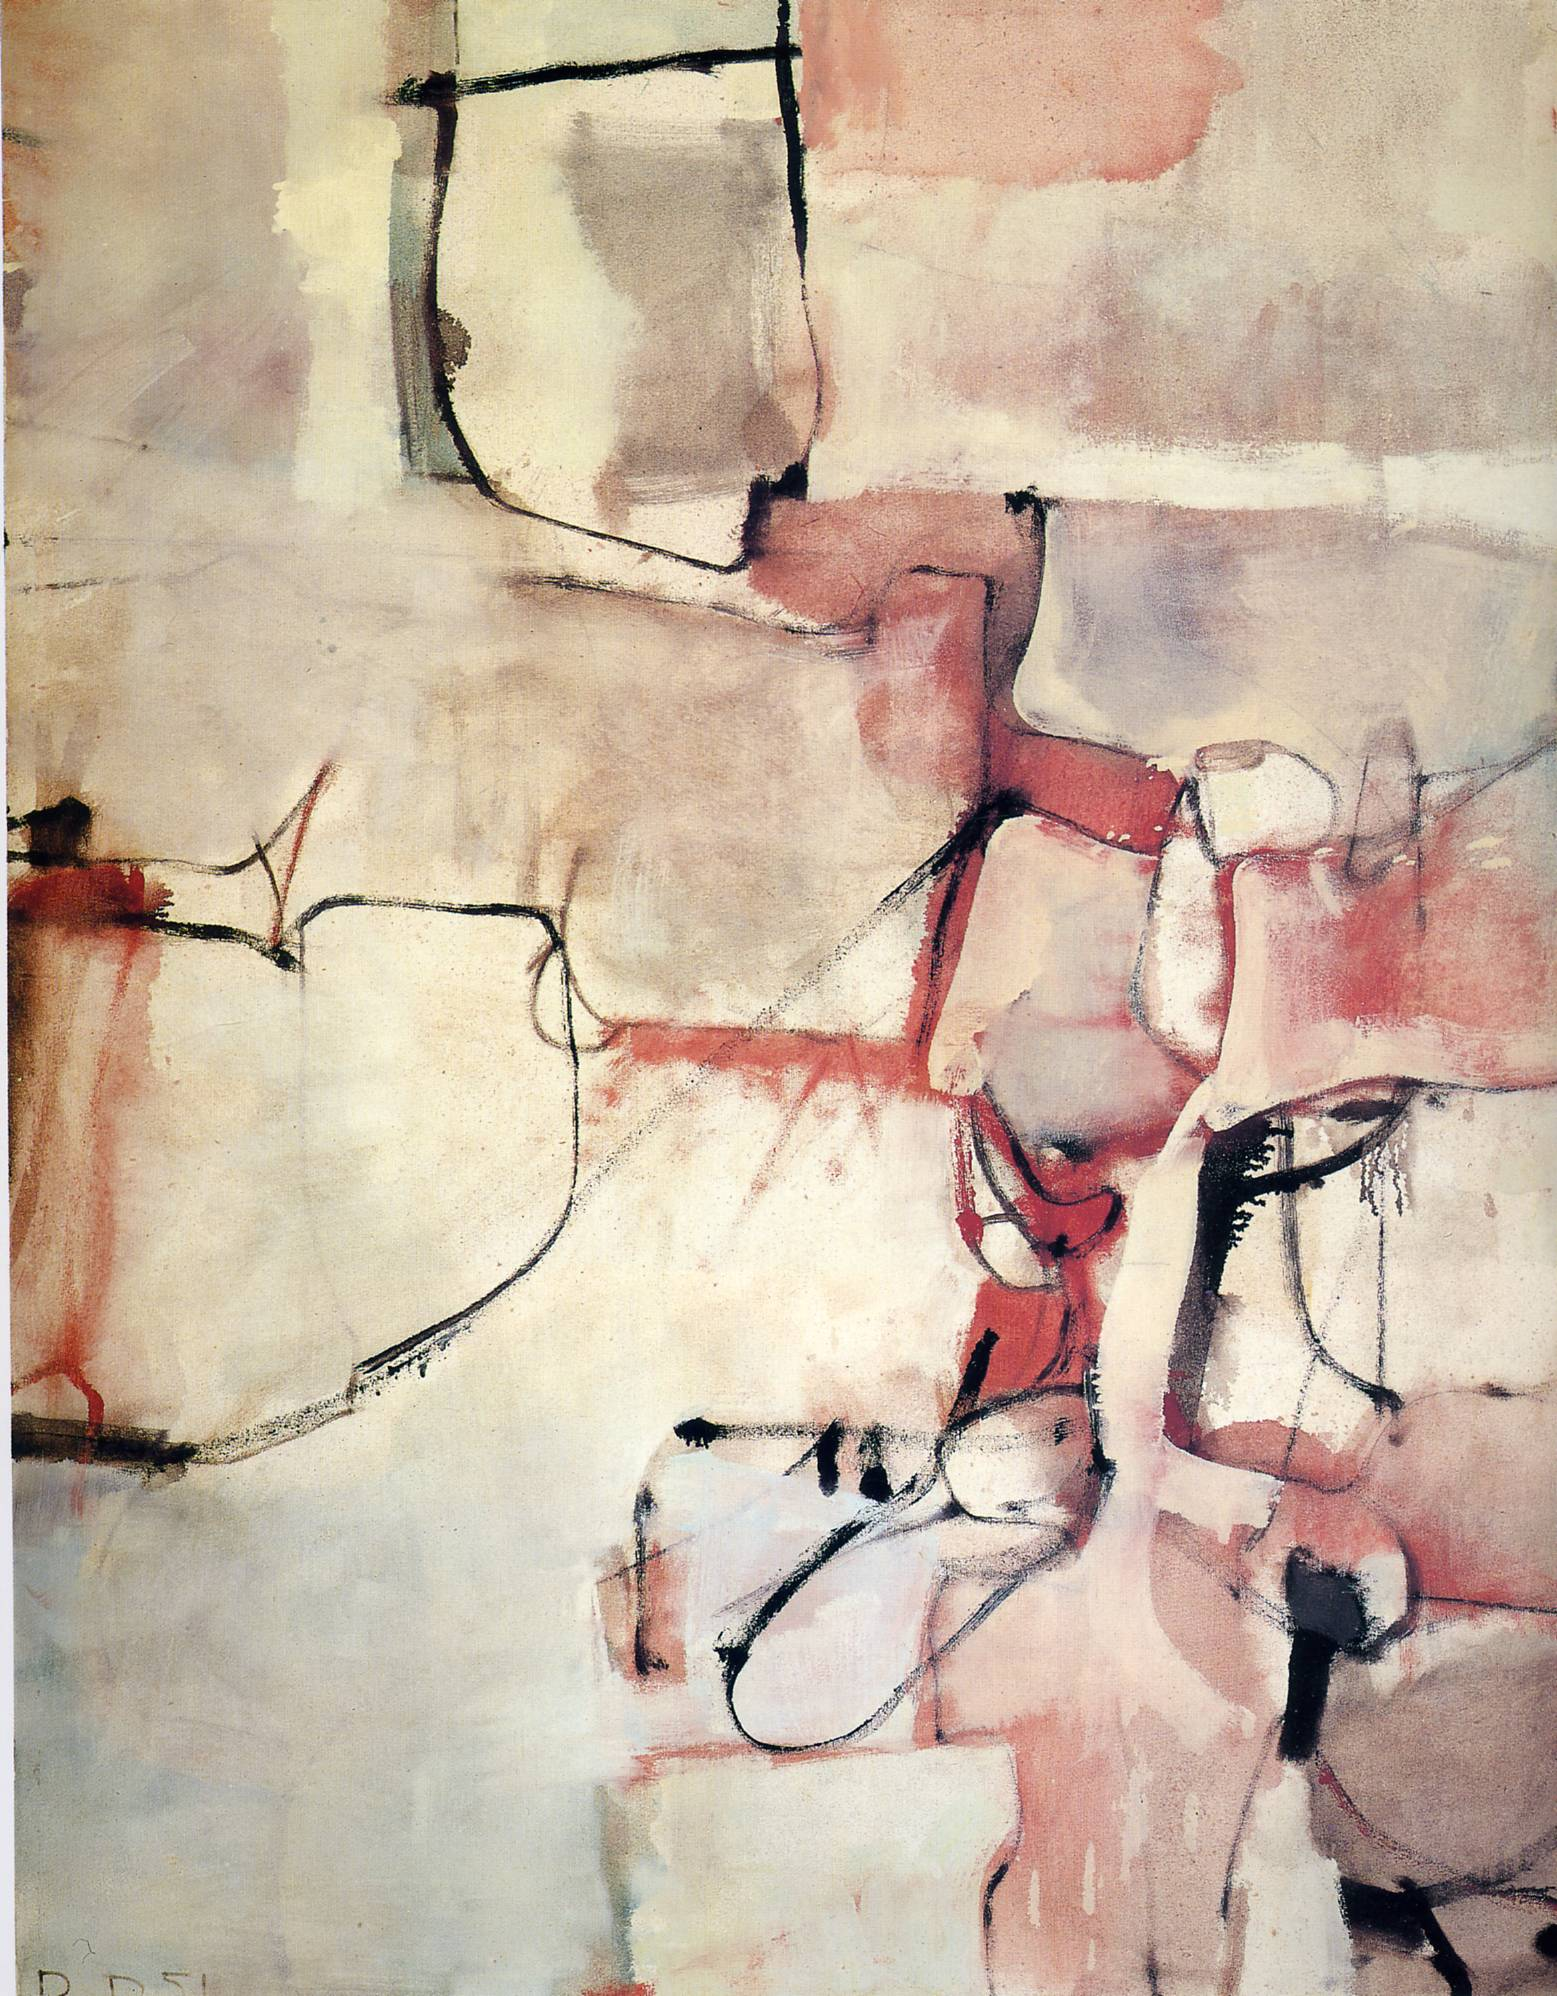Can you tell me the possible inspiration behind this artwork? The painting might be inspired by the artist's exploration of human emotions and experiences through abstract forms and vibrant colors. It can reflect a journey of self-discovery and introspection, expressed through the interaction of lines, shapes, and colors. The blank spaces might symbolize moments of reflection, while the geometric shapes and dynamic lines could represent the complexity and ever-changing nature of life and emotions. What emotions do you think the artist is trying to convey through this artwork? The artist seems to be conveying a range of emotions such as introspection, contemplation, and perhaps even tension. The use of warm colors like red and pink suggests a certain warmth and intensity of feelings. The stark black lines add a sense of complexity and depth, potentially indicating inner conflict or the multifaceted nature of human emotions. The blank spaces might portray calmness or moments of clarity within the emotional turbulence. Imagine the kind of music that might complement this painting. What genre would it be, and why? A jazz piece might perfectly complement this painting. Jazz, with its improvisational nature and emotional depth, can mirror the spontaneous and abstract forms seen in the artwork. The ebb and flow of a jazz composition, with its layered melodies and harmonies, could enhance the viewer’s experience, providing a sonic backdrop to the visual exploration of form and color. If this artwork were a character in a story, what kind of character would it be? This artwork would be a complex and enigmatic character, perhaps an introspective philosopher or a passionate artist. They would possess a rich inner life, full of depth and emotional intensity, but might also have moments of quiet contemplation and clarity. This character would likely be deeply reflective, constantly navigating and expressing their emotions and thoughts through their art and interactions with the world. 